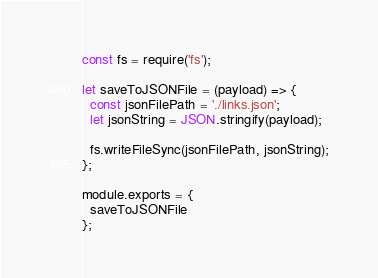<code> <loc_0><loc_0><loc_500><loc_500><_JavaScript_>const fs = require('fs');

let saveToJSONFile = (payload) => {
  const jsonFilePath = './links.json';
  let jsonString = JSON.stringify(payload);

  fs.writeFileSync(jsonFilePath, jsonString);
};

module.exports = {
  saveToJSONFile
};
</code> 